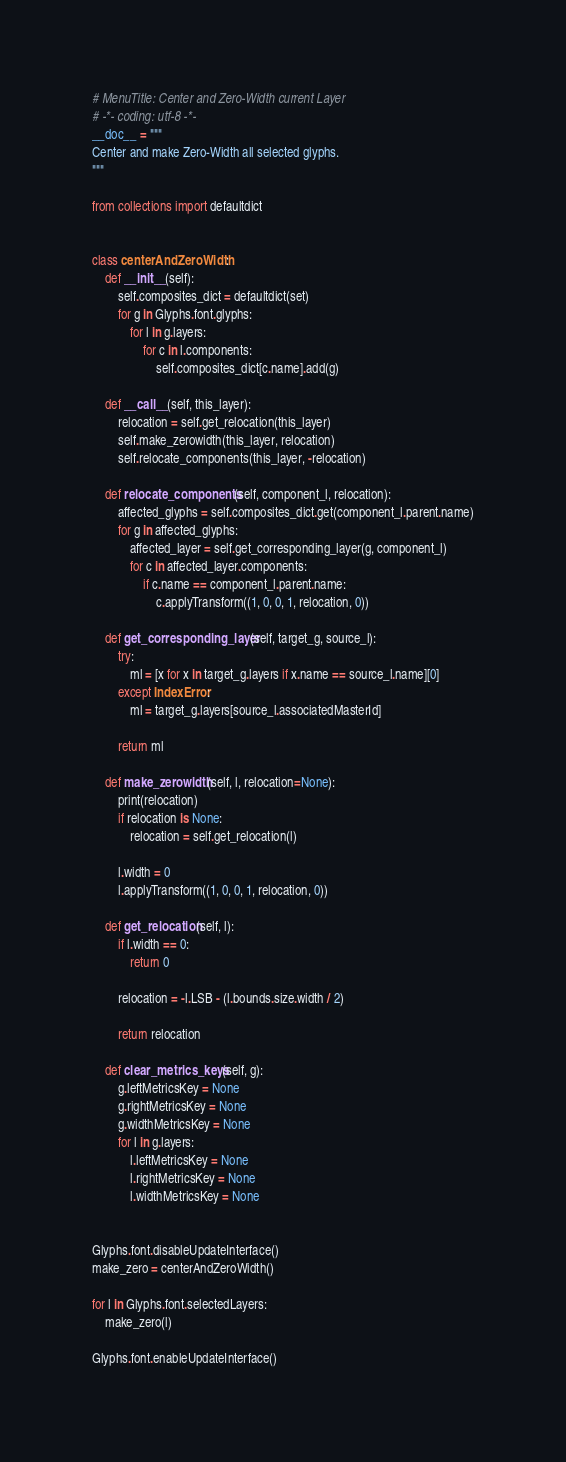<code> <loc_0><loc_0><loc_500><loc_500><_Python_># MenuTitle: Center and Zero-Width current Layer
# -*- coding: utf-8 -*-
__doc__ = """
Center and make Zero-Width all selected glyphs.
"""

from collections import defaultdict


class centerAndZeroWidth:
    def __init__(self):
        self.composites_dict = defaultdict(set)
        for g in Glyphs.font.glyphs:
            for l in g.layers:
                for c in l.components:
                    self.composites_dict[c.name].add(g)

    def __call__(self, this_layer):
        relocation = self.get_relocation(this_layer)
        self.make_zerowidth(this_layer, relocation)
        self.relocate_components(this_layer, -relocation)

    def relocate_components(self, component_l, relocation):
        affected_glyphs = self.composites_dict.get(component_l.parent.name)
        for g in affected_glyphs:
            affected_layer = self.get_corresponding_layer(g, component_l)
            for c in affected_layer.components:
                if c.name == component_l.parent.name:
                    c.applyTransform((1, 0, 0, 1, relocation, 0))

    def get_corresponding_layer(self, target_g, source_l):
        try:
            ml = [x for x in target_g.layers if x.name == source_l.name][0]
        except IndexError:
            ml = target_g.layers[source_l.associatedMasterId]

        return ml

    def make_zerowidth(self, l, relocation=None):
        print(relocation)
        if relocation is None:
            relocation = self.get_relocation(l)

        l.width = 0
        l.applyTransform((1, 0, 0, 1, relocation, 0))

    def get_relocation(self, l):
        if l.width == 0:
            return 0

        relocation = -l.LSB - (l.bounds.size.width / 2)

        return relocation

    def clear_metrics_keys(self, g):
        g.leftMetricsKey = None
        g.rightMetricsKey = None
        g.widthMetricsKey = None
        for l in g.layers:
            l.leftMetricsKey = None
            l.rightMetricsKey = None
            l.widthMetricsKey = None


Glyphs.font.disableUpdateInterface()
make_zero = centerAndZeroWidth()

for l in Glyphs.font.selectedLayers:
    make_zero(l)

Glyphs.font.enableUpdateInterface()
</code> 